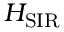Convert formula to latex. <formula><loc_0><loc_0><loc_500><loc_500>H _ { S I R }</formula> 